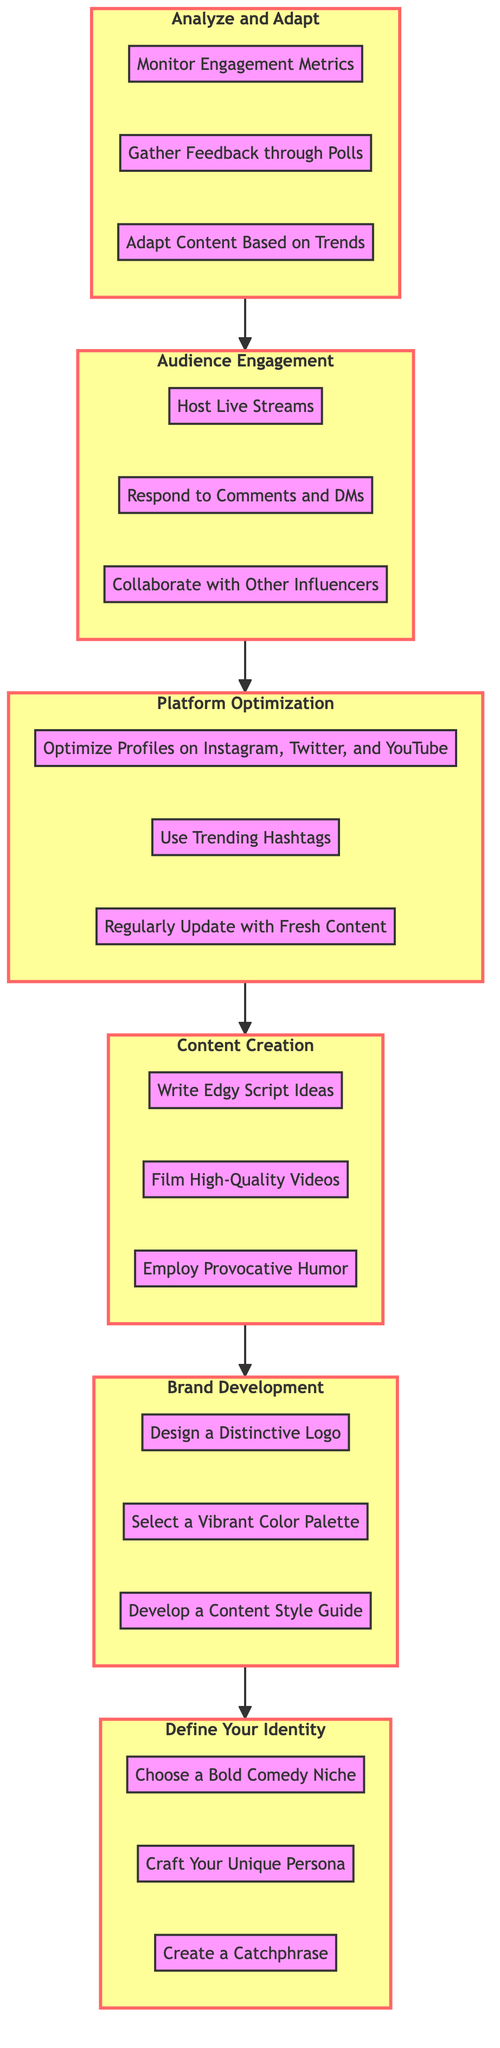What is the first stage in the diagram? The first stage is at the bottom of the flowchart, which is "Define Your Identity." It is the initial step before all other processes begin.
Answer: Define Your Identity How many actions are listed under "Brand Development"? By counting the actions in the "Brand Development" stage, there are three actions mentioned: "Design a Distinctive Logo," "Select a Vibrant Color Palette," and "Develop a Content Style Guide."
Answer: 3 Which action comes after "Host Live Streams"? Following the flow of the diagram upward from the "Audience Engagement" stage, after "Host Live Streams," the next action is "Respond to Comments and DMs."
Answer: Respond to Comments and DMs What stage follows "Platform Optimization"? Tracing the flow from "Platform Optimization," the next stage is "Content Creation." Each stage leads sequentially to the next.
Answer: Content Creation List all actions under "Audience Engagement". In the "Audience Engagement" stage, the actions are identified as "Host Live Streams," "Respond to Comments and DMs," and "Collaborate with Other Influencers."
Answer: Host Live Streams, Respond to Comments and DMs, Collaborate with Other Influencers Which stage involves creating a catchphrase? A catchphrase is developed in the "Define Your Identity" stage, which focuses on establishing the foundational elements of the influencer's persona, including a catchphrase.
Answer: Define Your Identity How does "Analyze and Adapt" connect to "Audience Engagement"? The "Analyze and Adapt" stage is connected to the "Audience Engagement" stage as the last step in the flow, indicating that after engaging the audience, an analysis of that engagement is necessary for further adaptation.
Answer: Connects from Analyze and Adapt to Audience Engagement What is the relationship between "Content Creation" and "Brand Development"? "Content Creation" and "Brand Development" are directly connected in the diagram, where "Content Creation" follows "Platform Optimization," while "Brand Development" is before "Content Creation." This indicates a progression in the process from establishing the brand to creating content.
Answer: Sequential interconnection Which stage contains the action "Employ Provocative Humor"? The action "Employ Provocative Humor" is found within the "Content Creation" stage, which is focused on the development of engaging and bold content.
Answer: Content Creation 